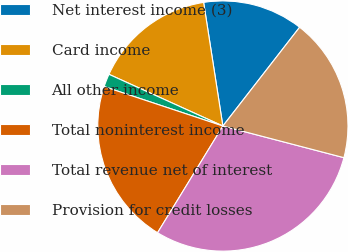<chart> <loc_0><loc_0><loc_500><loc_500><pie_chart><fcel>Net interest income (3)<fcel>Card income<fcel>All other income<fcel>Total noninterest income<fcel>Total revenue net of interest<fcel>Provision for credit losses<nl><fcel>12.97%<fcel>15.76%<fcel>1.68%<fcel>21.36%<fcel>29.67%<fcel>18.56%<nl></chart> 